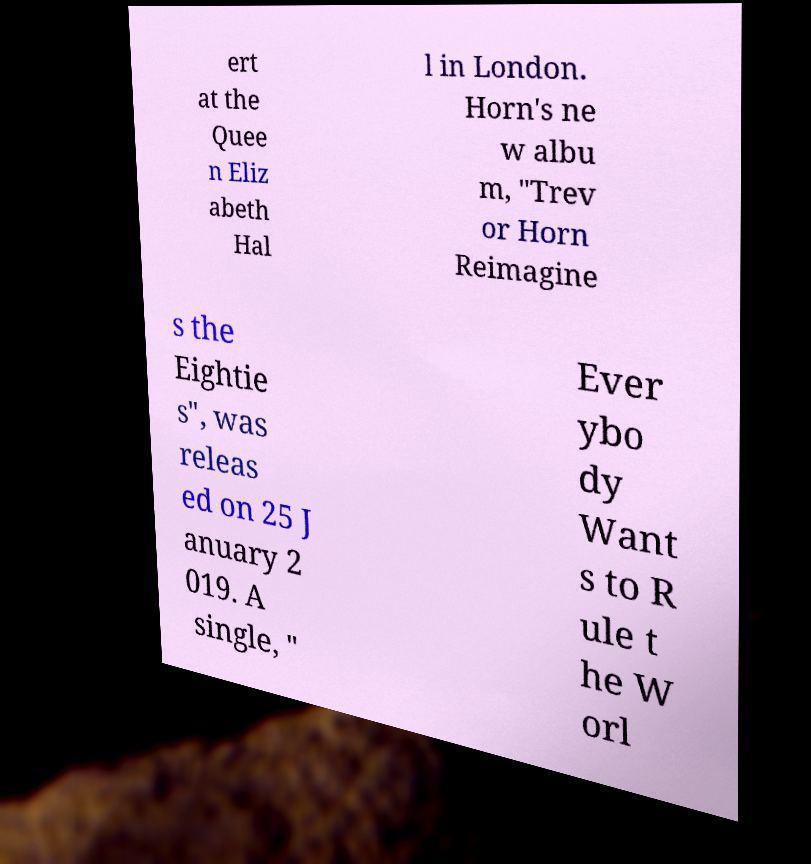Can you read and provide the text displayed in the image?This photo seems to have some interesting text. Can you extract and type it out for me? ert at the Quee n Eliz abeth Hal l in London. Horn's ne w albu m, "Trev or Horn Reimagine s the Eightie s", was releas ed on 25 J anuary 2 019. A single, " Ever ybo dy Want s to R ule t he W orl 